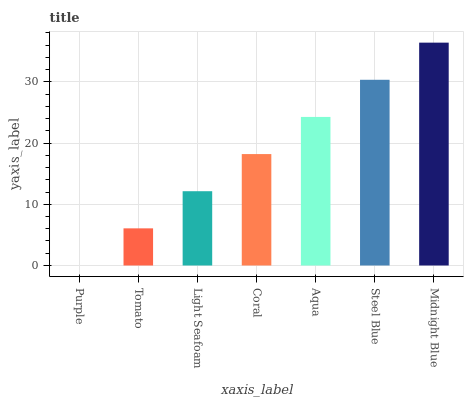Is Purple the minimum?
Answer yes or no. Yes. Is Midnight Blue the maximum?
Answer yes or no. Yes. Is Tomato the minimum?
Answer yes or no. No. Is Tomato the maximum?
Answer yes or no. No. Is Tomato greater than Purple?
Answer yes or no. Yes. Is Purple less than Tomato?
Answer yes or no. Yes. Is Purple greater than Tomato?
Answer yes or no. No. Is Tomato less than Purple?
Answer yes or no. No. Is Coral the high median?
Answer yes or no. Yes. Is Coral the low median?
Answer yes or no. Yes. Is Aqua the high median?
Answer yes or no. No. Is Aqua the low median?
Answer yes or no. No. 